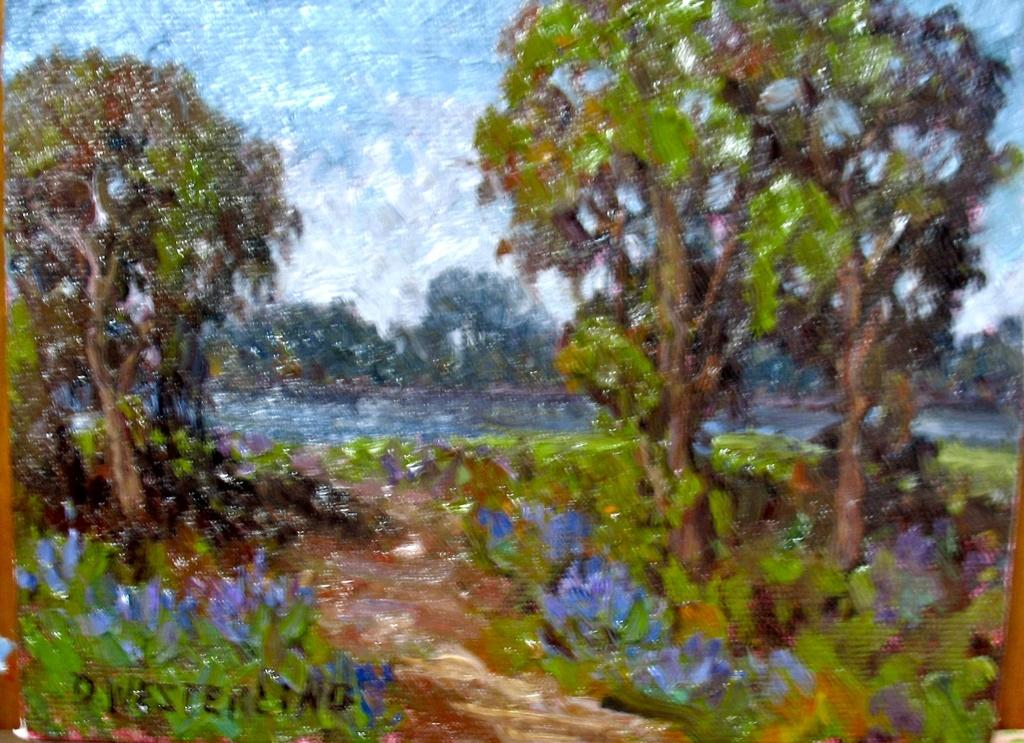What is the main subject of the image? The image contains a painting. What is depicted in the painting? The painting depicts trees, plants, water, and the sky. Where are the words located in the image? The words are at the bottom left corner of the image. How many bells can be seen in the painting? There are no bells depicted in the painting; it features trees, plants, water, and the sky. What type of chairs are present in the painting? There are no chairs depicted in the painting; it features trees, plants, water, and the sky. 